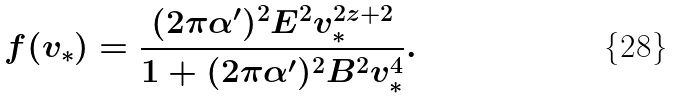Convert formula to latex. <formula><loc_0><loc_0><loc_500><loc_500>f ( v _ { \ast } ) = \frac { ( 2 \pi \alpha ^ { \prime } ) ^ { 2 } E ^ { 2 } v ^ { 2 z + 2 } _ { \ast } } { 1 + ( 2 \pi \alpha ^ { \prime } ) ^ { 2 } B ^ { 2 } v _ { \ast } ^ { 4 } } .</formula> 